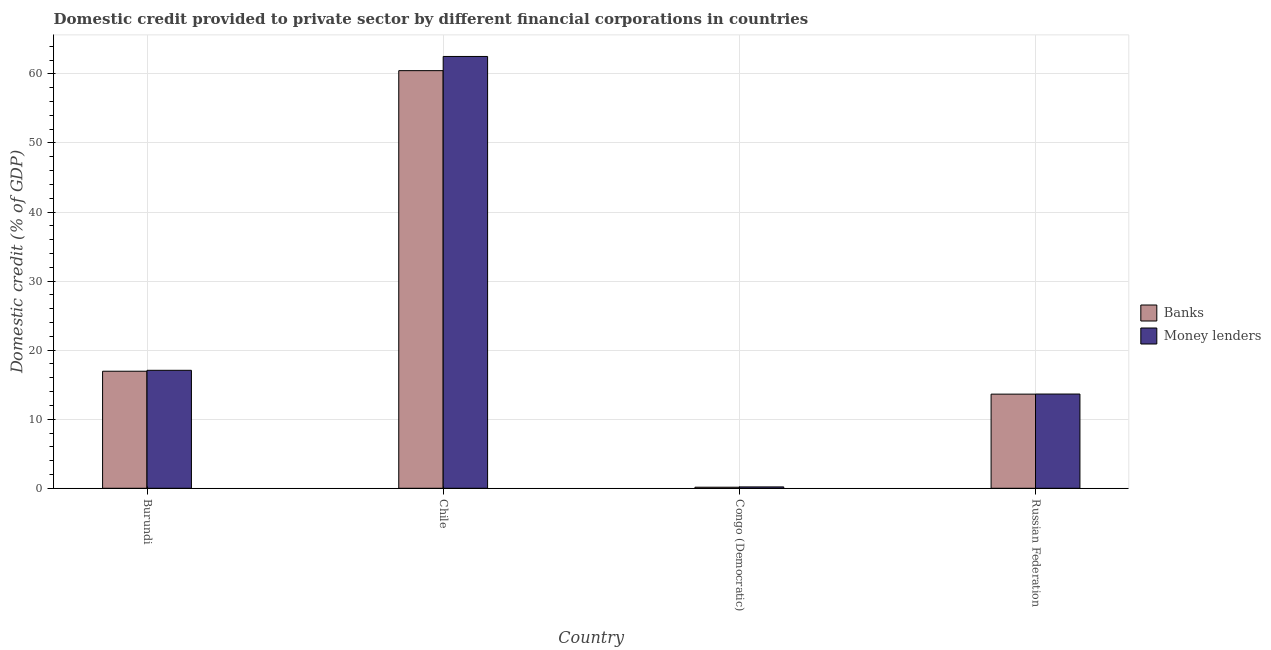How many groups of bars are there?
Make the answer very short. 4. Are the number of bars on each tick of the X-axis equal?
Provide a succinct answer. Yes. What is the label of the 1st group of bars from the left?
Keep it short and to the point. Burundi. What is the domestic credit provided by money lenders in Chile?
Give a very brief answer. 62.52. Across all countries, what is the maximum domestic credit provided by banks?
Your answer should be compact. 60.47. Across all countries, what is the minimum domestic credit provided by banks?
Make the answer very short. 0.15. In which country was the domestic credit provided by banks minimum?
Provide a short and direct response. Congo (Democratic). What is the total domestic credit provided by banks in the graph?
Your answer should be compact. 91.2. What is the difference between the domestic credit provided by banks in Chile and that in Russian Federation?
Make the answer very short. 46.84. What is the difference between the domestic credit provided by banks in Chile and the domestic credit provided by money lenders in Burundi?
Your answer should be very brief. 43.39. What is the average domestic credit provided by banks per country?
Make the answer very short. 22.8. What is the difference between the domestic credit provided by banks and domestic credit provided by money lenders in Congo (Democratic)?
Your response must be concise. -0.04. What is the ratio of the domestic credit provided by money lenders in Burundi to that in Chile?
Your response must be concise. 0.27. Is the difference between the domestic credit provided by money lenders in Congo (Democratic) and Russian Federation greater than the difference between the domestic credit provided by banks in Congo (Democratic) and Russian Federation?
Provide a succinct answer. Yes. What is the difference between the highest and the second highest domestic credit provided by banks?
Your response must be concise. 43.52. What is the difference between the highest and the lowest domestic credit provided by money lenders?
Give a very brief answer. 62.32. In how many countries, is the domestic credit provided by banks greater than the average domestic credit provided by banks taken over all countries?
Provide a succinct answer. 1. Is the sum of the domestic credit provided by money lenders in Chile and Russian Federation greater than the maximum domestic credit provided by banks across all countries?
Ensure brevity in your answer.  Yes. What does the 2nd bar from the left in Congo (Democratic) represents?
Provide a succinct answer. Money lenders. What does the 1st bar from the right in Burundi represents?
Your answer should be very brief. Money lenders. Are all the bars in the graph horizontal?
Offer a terse response. No. How many countries are there in the graph?
Offer a very short reply. 4. What is the difference between two consecutive major ticks on the Y-axis?
Give a very brief answer. 10. Are the values on the major ticks of Y-axis written in scientific E-notation?
Your response must be concise. No. Does the graph contain grids?
Make the answer very short. Yes. How many legend labels are there?
Provide a succinct answer. 2. How are the legend labels stacked?
Keep it short and to the point. Vertical. What is the title of the graph?
Provide a succinct answer. Domestic credit provided to private sector by different financial corporations in countries. What is the label or title of the X-axis?
Ensure brevity in your answer.  Country. What is the label or title of the Y-axis?
Give a very brief answer. Domestic credit (% of GDP). What is the Domestic credit (% of GDP) of Banks in Burundi?
Ensure brevity in your answer.  16.95. What is the Domestic credit (% of GDP) in Money lenders in Burundi?
Your answer should be very brief. 17.08. What is the Domestic credit (% of GDP) of Banks in Chile?
Provide a short and direct response. 60.47. What is the Domestic credit (% of GDP) of Money lenders in Chile?
Offer a terse response. 62.52. What is the Domestic credit (% of GDP) in Banks in Congo (Democratic)?
Keep it short and to the point. 0.15. What is the Domestic credit (% of GDP) in Money lenders in Congo (Democratic)?
Your response must be concise. 0.2. What is the Domestic credit (% of GDP) in Banks in Russian Federation?
Offer a terse response. 13.63. What is the Domestic credit (% of GDP) of Money lenders in Russian Federation?
Your answer should be very brief. 13.65. Across all countries, what is the maximum Domestic credit (% of GDP) of Banks?
Your answer should be compact. 60.47. Across all countries, what is the maximum Domestic credit (% of GDP) of Money lenders?
Offer a very short reply. 62.52. Across all countries, what is the minimum Domestic credit (% of GDP) in Banks?
Your answer should be very brief. 0.15. Across all countries, what is the minimum Domestic credit (% of GDP) in Money lenders?
Ensure brevity in your answer.  0.2. What is the total Domestic credit (% of GDP) of Banks in the graph?
Ensure brevity in your answer.  91.2. What is the total Domestic credit (% of GDP) of Money lenders in the graph?
Your answer should be very brief. 93.44. What is the difference between the Domestic credit (% of GDP) in Banks in Burundi and that in Chile?
Provide a succinct answer. -43.52. What is the difference between the Domestic credit (% of GDP) of Money lenders in Burundi and that in Chile?
Your answer should be compact. -45.44. What is the difference between the Domestic credit (% of GDP) of Banks in Burundi and that in Congo (Democratic)?
Your answer should be compact. 16.79. What is the difference between the Domestic credit (% of GDP) of Money lenders in Burundi and that in Congo (Democratic)?
Give a very brief answer. 16.88. What is the difference between the Domestic credit (% of GDP) of Banks in Burundi and that in Russian Federation?
Offer a terse response. 3.32. What is the difference between the Domestic credit (% of GDP) in Money lenders in Burundi and that in Russian Federation?
Your response must be concise. 3.43. What is the difference between the Domestic credit (% of GDP) of Banks in Chile and that in Congo (Democratic)?
Provide a short and direct response. 60.31. What is the difference between the Domestic credit (% of GDP) of Money lenders in Chile and that in Congo (Democratic)?
Give a very brief answer. 62.32. What is the difference between the Domestic credit (% of GDP) in Banks in Chile and that in Russian Federation?
Keep it short and to the point. 46.84. What is the difference between the Domestic credit (% of GDP) in Money lenders in Chile and that in Russian Federation?
Make the answer very short. 48.87. What is the difference between the Domestic credit (% of GDP) of Banks in Congo (Democratic) and that in Russian Federation?
Offer a terse response. -13.48. What is the difference between the Domestic credit (% of GDP) of Money lenders in Congo (Democratic) and that in Russian Federation?
Your answer should be very brief. -13.45. What is the difference between the Domestic credit (% of GDP) in Banks in Burundi and the Domestic credit (% of GDP) in Money lenders in Chile?
Ensure brevity in your answer.  -45.57. What is the difference between the Domestic credit (% of GDP) of Banks in Burundi and the Domestic credit (% of GDP) of Money lenders in Congo (Democratic)?
Your answer should be very brief. 16.75. What is the difference between the Domestic credit (% of GDP) in Banks in Burundi and the Domestic credit (% of GDP) in Money lenders in Russian Federation?
Provide a succinct answer. 3.3. What is the difference between the Domestic credit (% of GDP) of Banks in Chile and the Domestic credit (% of GDP) of Money lenders in Congo (Democratic)?
Provide a short and direct response. 60.27. What is the difference between the Domestic credit (% of GDP) in Banks in Chile and the Domestic credit (% of GDP) in Money lenders in Russian Federation?
Offer a terse response. 46.82. What is the difference between the Domestic credit (% of GDP) in Banks in Congo (Democratic) and the Domestic credit (% of GDP) in Money lenders in Russian Federation?
Your answer should be compact. -13.49. What is the average Domestic credit (% of GDP) in Banks per country?
Your response must be concise. 22.8. What is the average Domestic credit (% of GDP) of Money lenders per country?
Offer a very short reply. 23.36. What is the difference between the Domestic credit (% of GDP) of Banks and Domestic credit (% of GDP) of Money lenders in Burundi?
Offer a terse response. -0.13. What is the difference between the Domestic credit (% of GDP) of Banks and Domestic credit (% of GDP) of Money lenders in Chile?
Give a very brief answer. -2.05. What is the difference between the Domestic credit (% of GDP) of Banks and Domestic credit (% of GDP) of Money lenders in Congo (Democratic)?
Your answer should be compact. -0.04. What is the difference between the Domestic credit (% of GDP) of Banks and Domestic credit (% of GDP) of Money lenders in Russian Federation?
Keep it short and to the point. -0.02. What is the ratio of the Domestic credit (% of GDP) in Banks in Burundi to that in Chile?
Give a very brief answer. 0.28. What is the ratio of the Domestic credit (% of GDP) in Money lenders in Burundi to that in Chile?
Provide a short and direct response. 0.27. What is the ratio of the Domestic credit (% of GDP) in Banks in Burundi to that in Congo (Democratic)?
Ensure brevity in your answer.  109.87. What is the ratio of the Domestic credit (% of GDP) of Money lenders in Burundi to that in Congo (Democratic)?
Make the answer very short. 86.14. What is the ratio of the Domestic credit (% of GDP) of Banks in Burundi to that in Russian Federation?
Offer a very short reply. 1.24. What is the ratio of the Domestic credit (% of GDP) in Money lenders in Burundi to that in Russian Federation?
Your answer should be compact. 1.25. What is the ratio of the Domestic credit (% of GDP) in Banks in Chile to that in Congo (Democratic)?
Offer a very short reply. 391.99. What is the ratio of the Domestic credit (% of GDP) of Money lenders in Chile to that in Congo (Democratic)?
Ensure brevity in your answer.  315.3. What is the ratio of the Domestic credit (% of GDP) of Banks in Chile to that in Russian Federation?
Provide a succinct answer. 4.44. What is the ratio of the Domestic credit (% of GDP) of Money lenders in Chile to that in Russian Federation?
Provide a short and direct response. 4.58. What is the ratio of the Domestic credit (% of GDP) of Banks in Congo (Democratic) to that in Russian Federation?
Ensure brevity in your answer.  0.01. What is the ratio of the Domestic credit (% of GDP) of Money lenders in Congo (Democratic) to that in Russian Federation?
Offer a terse response. 0.01. What is the difference between the highest and the second highest Domestic credit (% of GDP) of Banks?
Make the answer very short. 43.52. What is the difference between the highest and the second highest Domestic credit (% of GDP) in Money lenders?
Offer a very short reply. 45.44. What is the difference between the highest and the lowest Domestic credit (% of GDP) in Banks?
Offer a very short reply. 60.31. What is the difference between the highest and the lowest Domestic credit (% of GDP) of Money lenders?
Give a very brief answer. 62.32. 